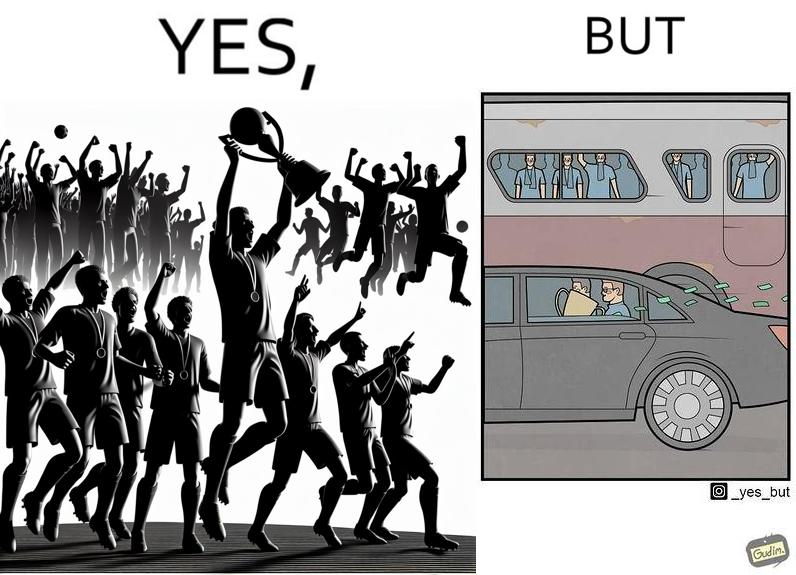Explain why this image is satirical. The image is ironical, as a team and its are all celebrating on the ground after winning the match, but after the match, the fans are standing in the bus uncomfortably, while the players are travelling inside a carring the cup as well as the prize money, which the fans did not get a dime of. 